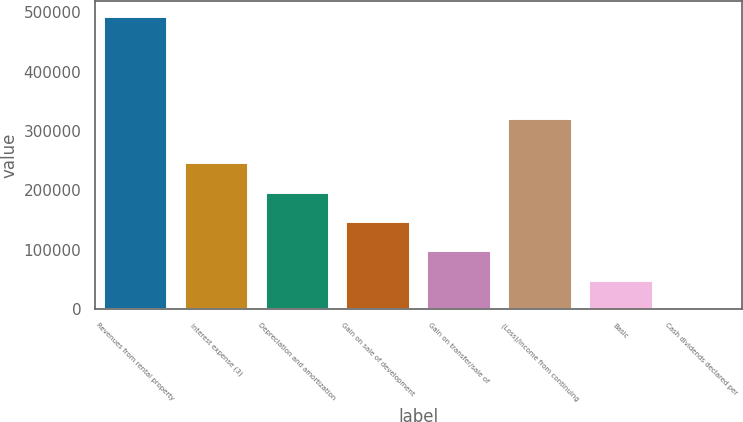Convert chart to OTSL. <chart><loc_0><loc_0><loc_500><loc_500><bar_chart><fcel>Revenues from rental property<fcel>Interest expense (3)<fcel>Depreciation and amortization<fcel>Gain on sale of development<fcel>Gain on transfer/sale of<fcel>(Loss)/income from continuing<fcel>Basic<fcel>Cash dividends declared per<nl><fcel>494467<fcel>247234<fcel>197788<fcel>148341<fcel>98894.4<fcel>321646<fcel>49447.8<fcel>1.27<nl></chart> 